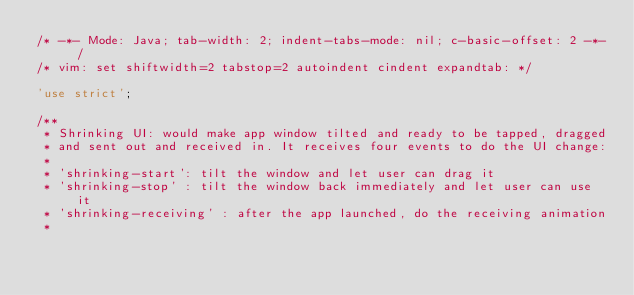Convert code to text. <code><loc_0><loc_0><loc_500><loc_500><_JavaScript_>/* -*- Mode: Java; tab-width: 2; indent-tabs-mode: nil; c-basic-offset: 2 -*- /
/* vim: set shiftwidth=2 tabstop=2 autoindent cindent expandtab: */

'use strict';

/**
 * Shrinking UI: would make app window tilted and ready to be tapped, dragged
 * and sent out and received in. It receives four events to do the UI change:
 *
 * 'shrinking-start': tilt the window and let user can drag it
 * 'shrinking-stop' : tilt the window back immediately and let user can use it
 * 'shrinking-receiving' : after the app launched, do the receiving animation
 *</code> 